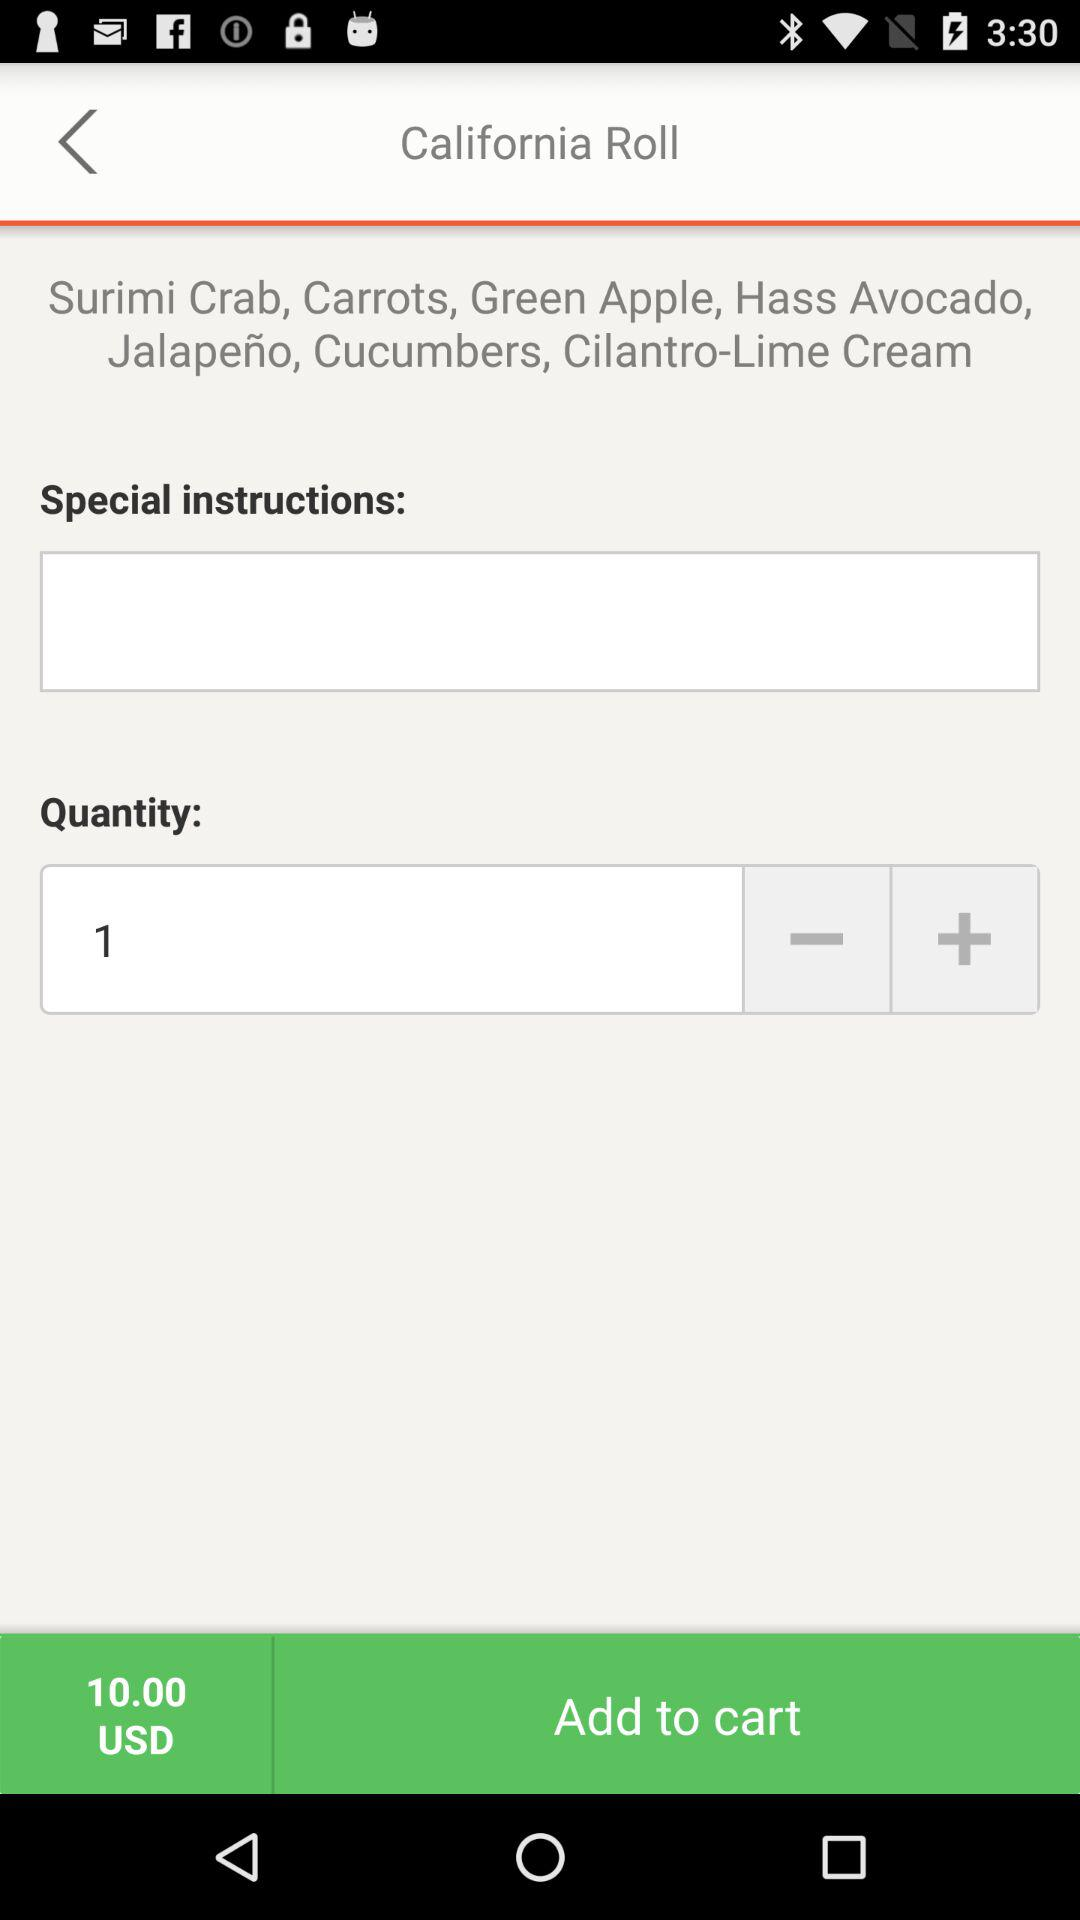What amount is mentioned in the cart? The mentioned amount is 10 USD. 